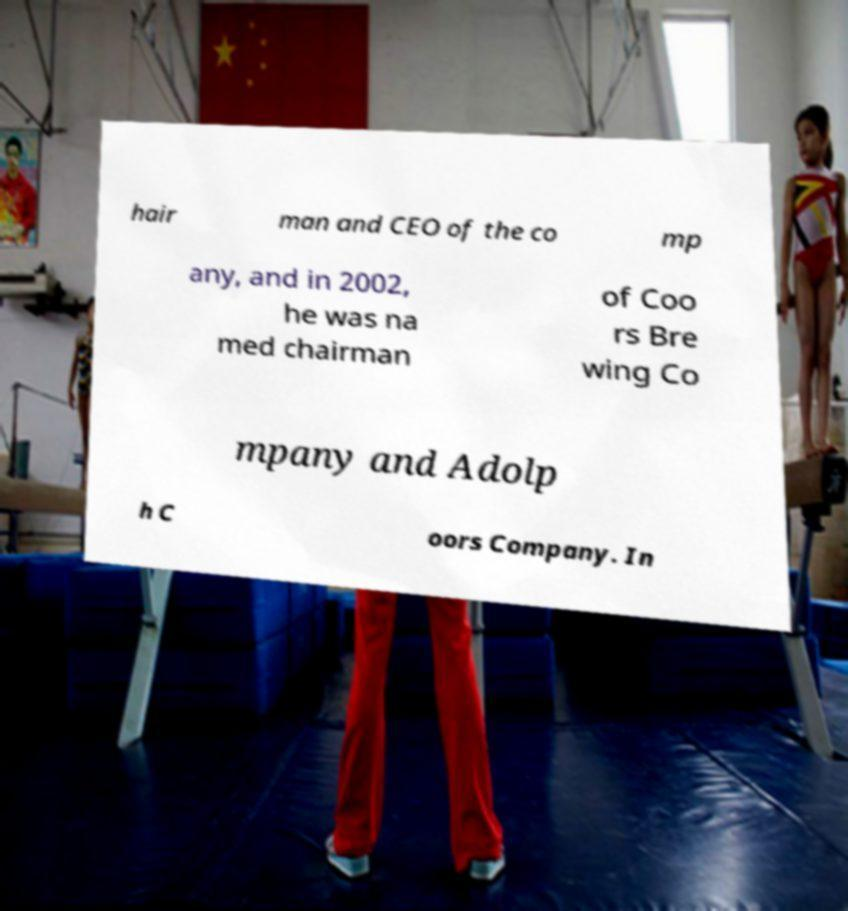Can you accurately transcribe the text from the provided image for me? hair man and CEO of the co mp any, and in 2002, he was na med chairman of Coo rs Bre wing Co mpany and Adolp h C oors Company. In 